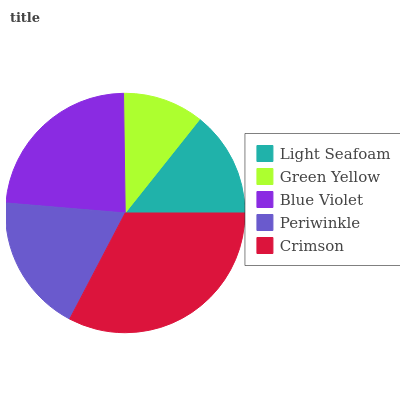Is Green Yellow the minimum?
Answer yes or no. Yes. Is Crimson the maximum?
Answer yes or no. Yes. Is Blue Violet the minimum?
Answer yes or no. No. Is Blue Violet the maximum?
Answer yes or no. No. Is Blue Violet greater than Green Yellow?
Answer yes or no. Yes. Is Green Yellow less than Blue Violet?
Answer yes or no. Yes. Is Green Yellow greater than Blue Violet?
Answer yes or no. No. Is Blue Violet less than Green Yellow?
Answer yes or no. No. Is Periwinkle the high median?
Answer yes or no. Yes. Is Periwinkle the low median?
Answer yes or no. Yes. Is Crimson the high median?
Answer yes or no. No. Is Green Yellow the low median?
Answer yes or no. No. 